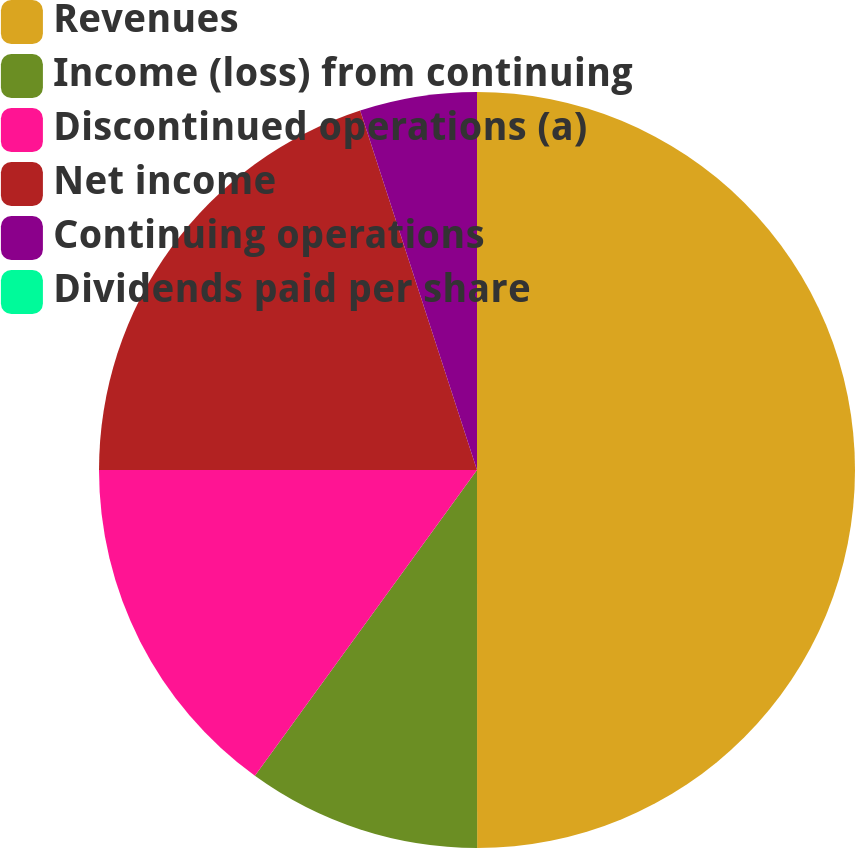Convert chart to OTSL. <chart><loc_0><loc_0><loc_500><loc_500><pie_chart><fcel>Revenues<fcel>Income (loss) from continuing<fcel>Discontinued operations (a)<fcel>Net income<fcel>Continuing operations<fcel>Dividends paid per share<nl><fcel>49.99%<fcel>10.0%<fcel>15.0%<fcel>20.0%<fcel>5.0%<fcel>0.0%<nl></chart> 